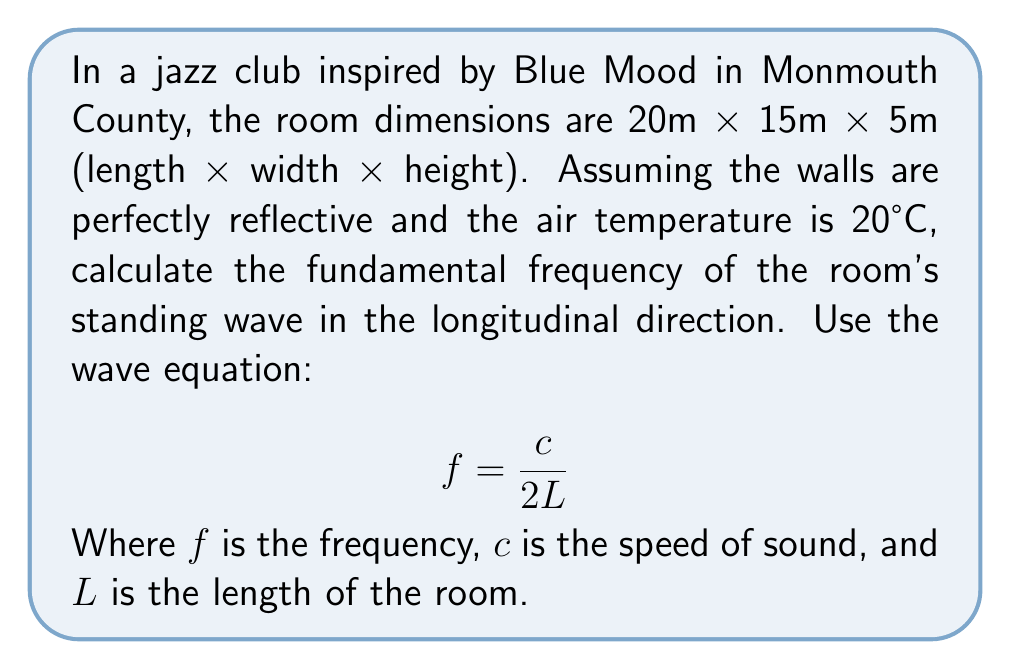Can you solve this math problem? To solve this problem, we'll follow these steps:

1. Determine the speed of sound ($c$) at 20°C:
   The speed of sound in air at 20°C is approximately 343 m/s.

2. Identify the length of the room ($L$):
   The length of the room is given as 20m.

3. Apply the wave equation for the fundamental frequency:
   $$f = \frac{c}{2L}$$

4. Substitute the values:
   $$f = \frac{343 \text{ m/s}}{2 \cdot 20 \text{ m}}$$

5. Calculate the result:
   $$f = \frac{343}{40} = 8.575 \text{ Hz}$$

6. Round to two decimal places:
   $f \approx 8.58 \text{ Hz}$

This frequency represents the fundamental standing wave in the longitudinal direction of the jazz club, which would contribute to its unique acoustic properties.
Answer: 8.58 Hz 